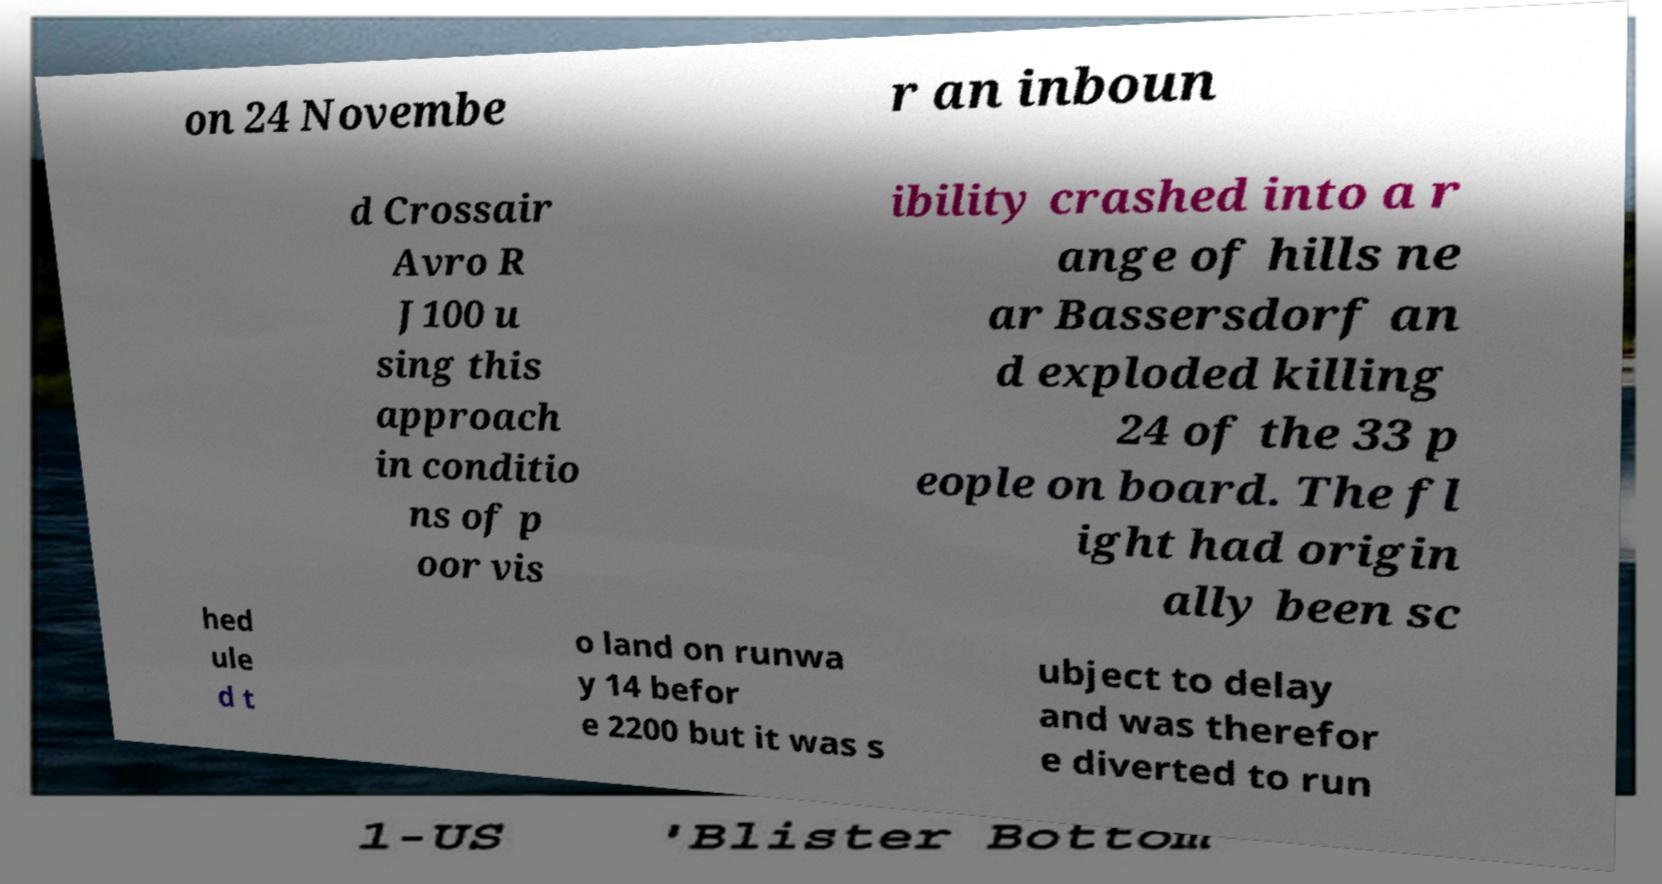Could you extract and type out the text from this image? on 24 Novembe r an inboun d Crossair Avro R J100 u sing this approach in conditio ns of p oor vis ibility crashed into a r ange of hills ne ar Bassersdorf an d exploded killing 24 of the 33 p eople on board. The fl ight had origin ally been sc hed ule d t o land on runwa y 14 befor e 2200 but it was s ubject to delay and was therefor e diverted to run 